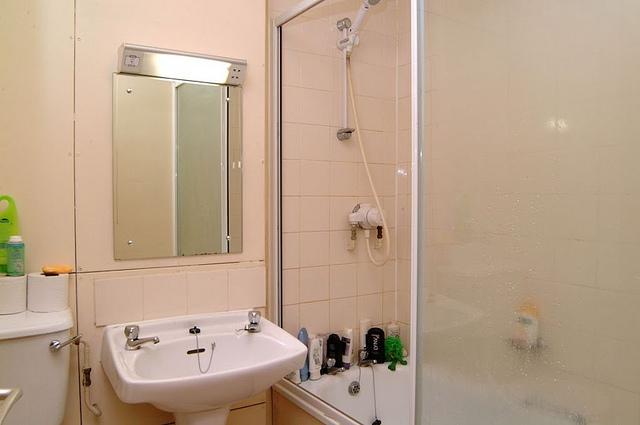Can you see the photographer?
Be succinct. No. Is this a hotel bathroom?
Short answer required. No. How many mirrors are in the picture?
Concise answer only. 1. What room of a house is this picture taken in?
Be succinct. Bathroom. Is this bathroom nice?
Write a very short answer. No. What is one brand of soap in the shower?
Short answer required. Ax. What is the green bottle used for?
Short answer required. Shampoo. 